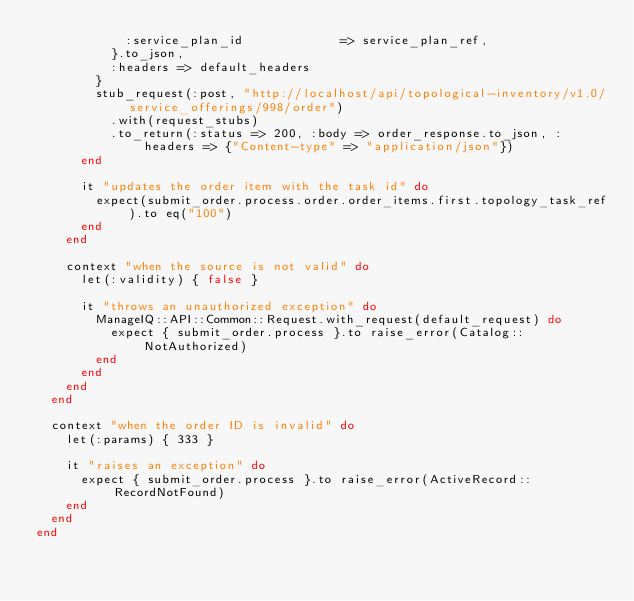Convert code to text. <code><loc_0><loc_0><loc_500><loc_500><_Ruby_>            :service_plan_id             => service_plan_ref,
          }.to_json,
          :headers => default_headers
        }
        stub_request(:post, "http://localhost/api/topological-inventory/v1.0/service_offerings/998/order")
          .with(request_stubs)
          .to_return(:status => 200, :body => order_response.to_json, :headers => {"Content-type" => "application/json"})
      end

      it "updates the order item with the task id" do
        expect(submit_order.process.order.order_items.first.topology_task_ref).to eq("100")
      end
    end

    context "when the source is not valid" do
      let(:validity) { false }

      it "throws an unauthorized exception" do
        ManageIQ::API::Common::Request.with_request(default_request) do
          expect { submit_order.process }.to raise_error(Catalog::NotAuthorized)
        end
      end
    end
  end

  context "when the order ID is invalid" do
    let(:params) { 333 }

    it "raises an exception" do
      expect { submit_order.process }.to raise_error(ActiveRecord::RecordNotFound)
    end
  end
end
</code> 